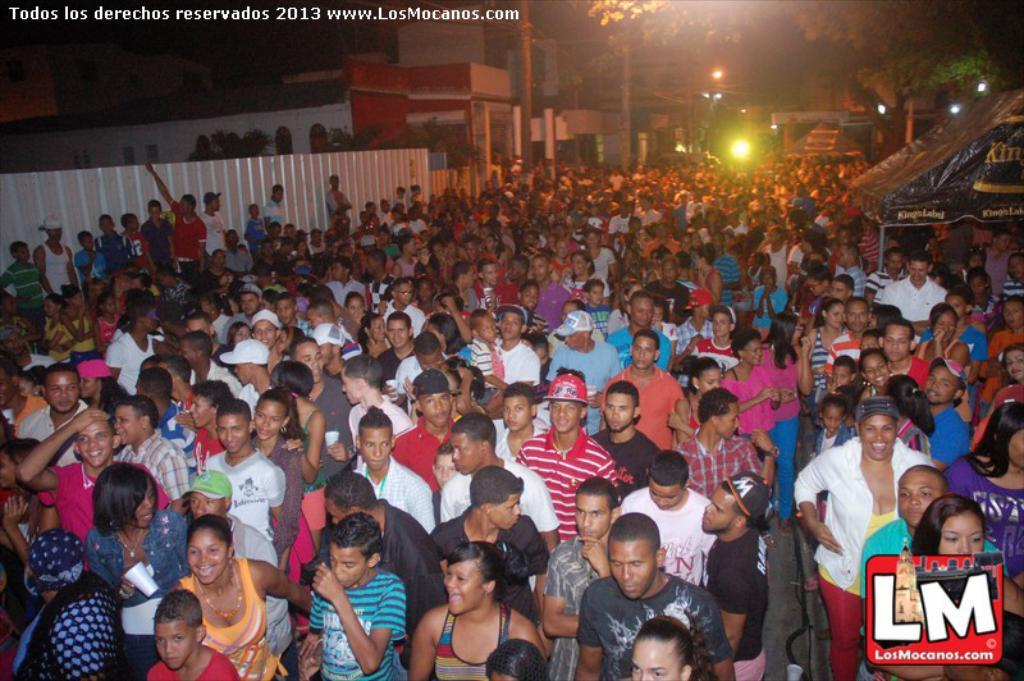How many people are in the image? There is a group of people in the image, but the exact number cannot be determined from the provided facts. What is on the left side of the image? There is a sheet on the left side of the image. What can be seen in the middle of the image? There are trees and houses in the middle of the image. What is present at the top of the image? There is a watermark at the top of the image. What type of milk is being served to the people in the image? There is no milk present in the image; it features a group of people, a sheet, trees and houses, and a watermark. 